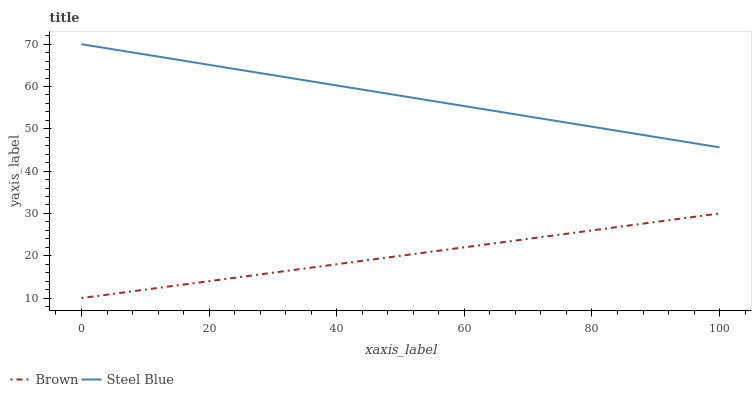Does Brown have the minimum area under the curve?
Answer yes or no. Yes. Does Steel Blue have the maximum area under the curve?
Answer yes or no. Yes. Does Steel Blue have the minimum area under the curve?
Answer yes or no. No. Is Brown the smoothest?
Answer yes or no. Yes. Is Steel Blue the roughest?
Answer yes or no. Yes. Is Steel Blue the smoothest?
Answer yes or no. No. Does Brown have the lowest value?
Answer yes or no. Yes. Does Steel Blue have the lowest value?
Answer yes or no. No. Does Steel Blue have the highest value?
Answer yes or no. Yes. Is Brown less than Steel Blue?
Answer yes or no. Yes. Is Steel Blue greater than Brown?
Answer yes or no. Yes. Does Brown intersect Steel Blue?
Answer yes or no. No. 